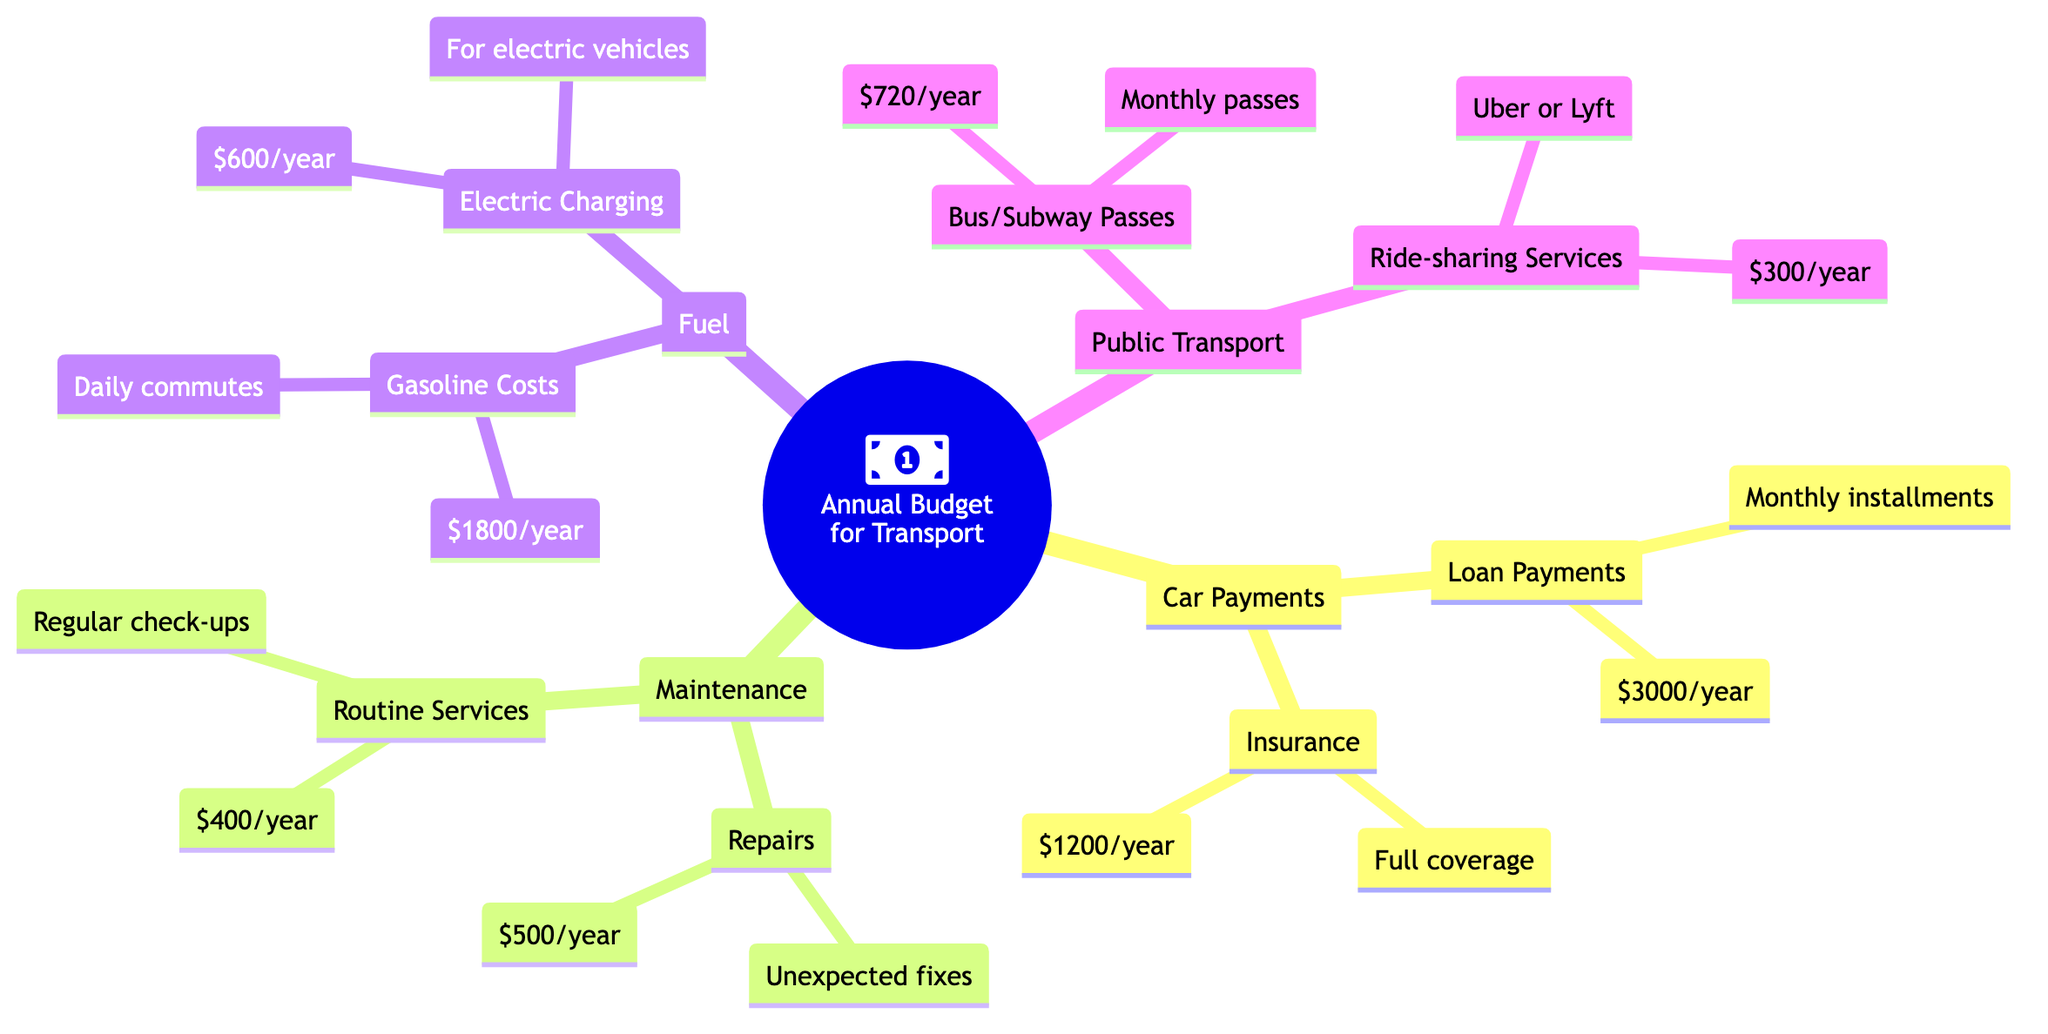what are the total annual car payments? To find the total annual car payments, we need to add the loan payments ($3000/year) and the insurance ($1200/year). Therefore, $3000 + $1200 = $4200.
Answer: 4200 how much is allocated for routine services? The amount allocated for routine services in the maintenance category is $400/year. This value can be found directly under the maintenance node.
Answer: 400 what is the total fuel cost annually? The total fuel cost can be calculated by adding the gasoline costs ($1800/year) and the electric charging costs ($600/year). So, $1800 + $600 = $2400/year.
Answer: 2400 how much do public transport passes cost per year? The cost for public transport passes is given as $720/year. This value is found under the public transport node.
Answer: 720 which expense category has the highest allocation? By comparing the categories, car payments ($4200) is the highest, followed by maintenance ($900). This can determine that car payments contribute the most to the annual budget allocation.
Answer: Car Payments what are the total expenses for maintenance? To get the total expenses for maintenance, we need to add repairs ($500/year) and routine services ($400/year). So, $500 + $400 = $900/year.
Answer: 900 how much does ride-sharing cost annually? The cost for ride-sharing services (like Uber or Lyft) is specified as $300/year under the public transport section.
Answer: 300 what is the combined cost for electric charging and gasoline? The combined cost for electric charging ($600/year) and gasoline ($1800/year) can be obtained by adding those two values: $600 + $1800 = $2400/year.
Answer: 2400 